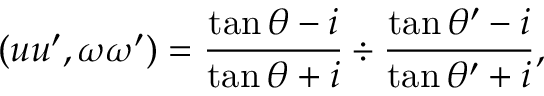<formula> <loc_0><loc_0><loc_500><loc_500>( u u ^ { \prime } , \omega \omega ^ { \prime } ) = { \frac { \tan \theta - i } { \tan \theta + i } } \div { \frac { \tan \theta ^ { \prime } - i } { \tan \theta ^ { \prime } + i } } ,</formula> 